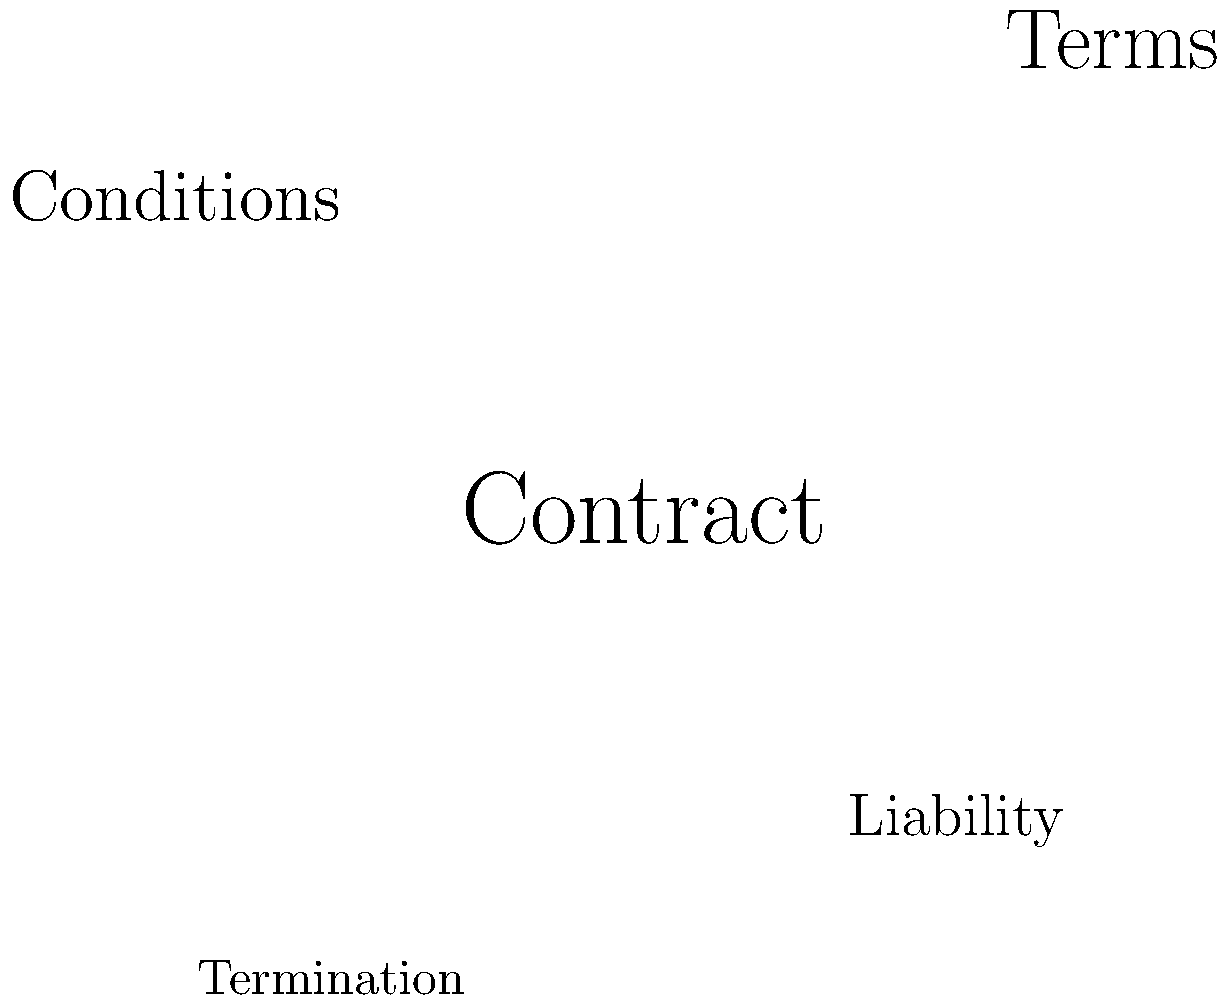Based on the word cloud and sentiment analysis chart provided, which of the following conclusions can be drawn about potential anomalies in the contract language? To analyze the potential anomalies in the contract language using the provided word cloud and sentiment analysis chart, we need to follow these steps:

1. Examine the word cloud:
   - The largest words represent the most frequently used terms in the contract.
   - "Contract," "Terms," and "Conditions" are prominent, which is expected in a standard agreement.
   - The word "Anomaly" is highlighted in red and larger than most other terms, indicating a potential issue.

2. Analyze the sentiment chart:
   - The x-axis represents time, and the y-axis represents sentiment (positive above 0, negative below 0).
   - The sentiment starts neutral (0), becomes positive (1), fluctuates, and then sharply drops to a negative value (-0.8) at the end.

3. Combine the insights:
   - The presence of "Anomaly" in the word cloud suggests unusual language or terms in the contract.
   - The sharp negative turn in sentiment at the end of the chart indicates a potentially unfavorable clause or condition.

4. Draw a conclusion:
   - The combination of the highlighted "Anomaly" in the word cloud and the sudden negative sentiment suggests that there is likely an unusual and potentially unfavorable clause near the end of the contract.

This analysis points to the presence of an anomaly in the contract language, specifically a clause that may be detrimental to one of the parties involved.
Answer: Unusual and potentially unfavorable clause near the end of the contract 